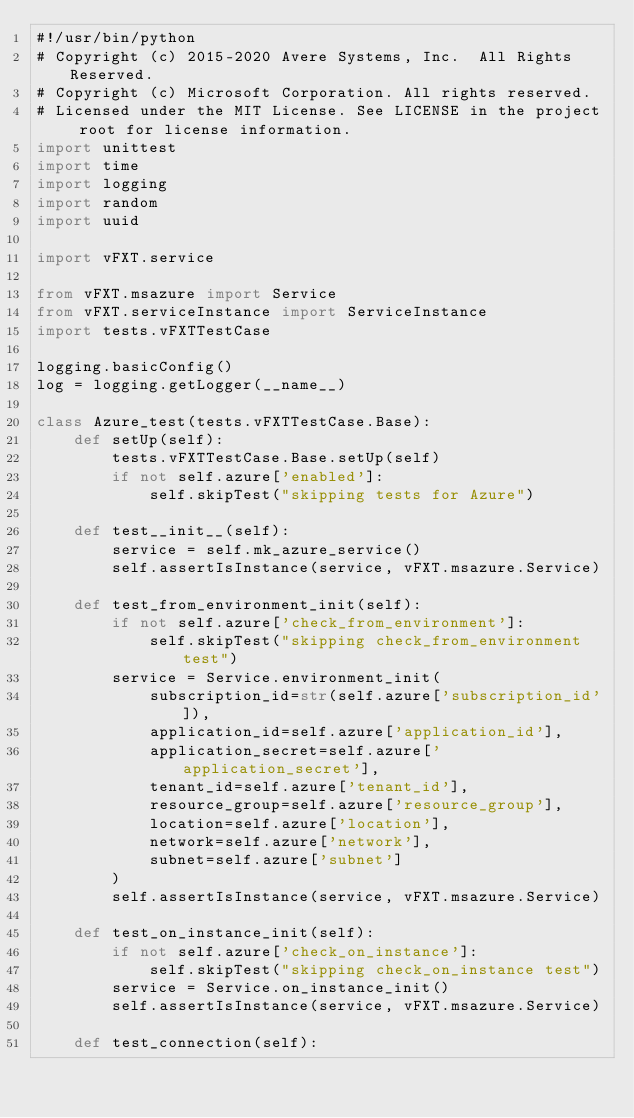<code> <loc_0><loc_0><loc_500><loc_500><_Python_>#!/usr/bin/python
# Copyright (c) 2015-2020 Avere Systems, Inc.  All Rights Reserved.
# Copyright (c) Microsoft Corporation. All rights reserved.
# Licensed under the MIT License. See LICENSE in the project root for license information.
import unittest
import time
import logging
import random
import uuid

import vFXT.service

from vFXT.msazure import Service
from vFXT.serviceInstance import ServiceInstance
import tests.vFXTTestCase

logging.basicConfig()
log = logging.getLogger(__name__)

class Azure_test(tests.vFXTTestCase.Base):
    def setUp(self):
        tests.vFXTTestCase.Base.setUp(self)
        if not self.azure['enabled']:
            self.skipTest("skipping tests for Azure")

    def test__init__(self):
        service = self.mk_azure_service()
        self.assertIsInstance(service, vFXT.msazure.Service)

    def test_from_environment_init(self):
        if not self.azure['check_from_environment']:
            self.skipTest("skipping check_from_environment test")
        service = Service.environment_init(
            subscription_id=str(self.azure['subscription_id']),
            application_id=self.azure['application_id'],
            application_secret=self.azure['application_secret'],
            tenant_id=self.azure['tenant_id'],
            resource_group=self.azure['resource_group'],
            location=self.azure['location'],
            network=self.azure['network'],
            subnet=self.azure['subnet']
        )
        self.assertIsInstance(service, vFXT.msazure.Service)

    def test_on_instance_init(self):
        if not self.azure['check_on_instance']:
            self.skipTest("skipping check_on_instance test")
        service = Service.on_instance_init()
        self.assertIsInstance(service, vFXT.msazure.Service)

    def test_connection(self):</code> 